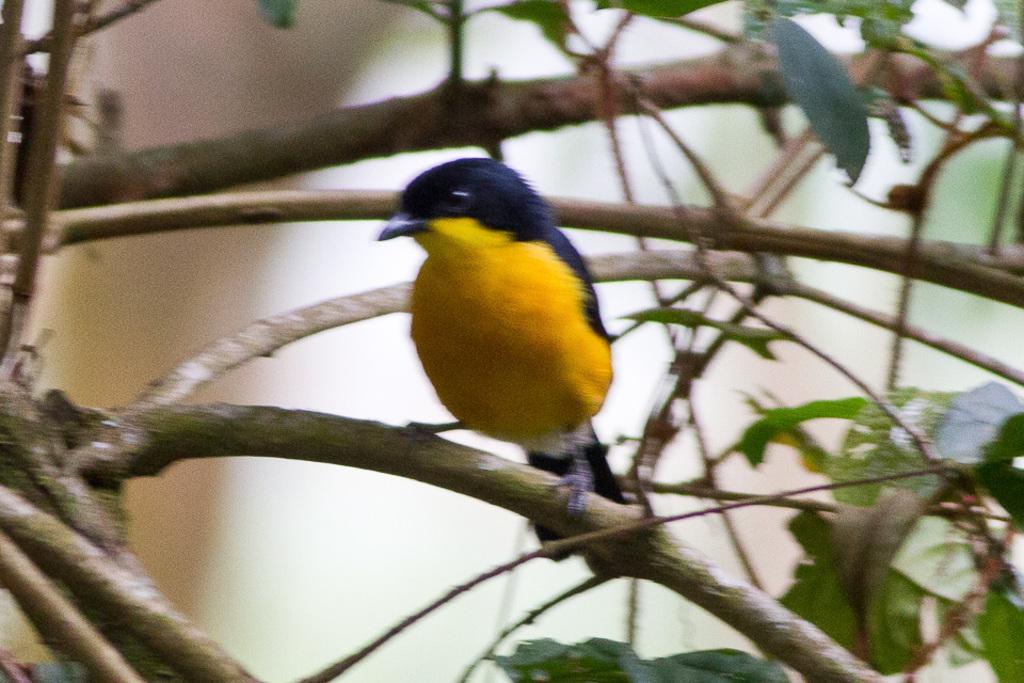Could you give a brief overview of what you see in this image? It is a blur image. In this image, we can see a bird is on the tree branch. Here we can see branches, stems and leaves. 